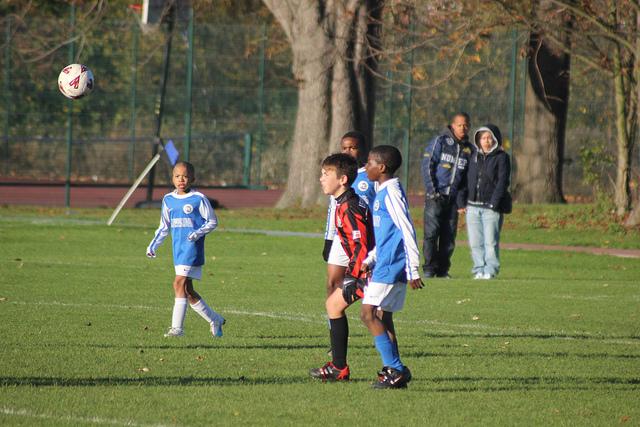How many boys are shown?
Give a very brief answer. 4. How many children wear blue and white uniforms?
Answer briefly. 3. How many people are playing?
Be succinct. 4. Where is the ball?
Quick response, please. In air. 